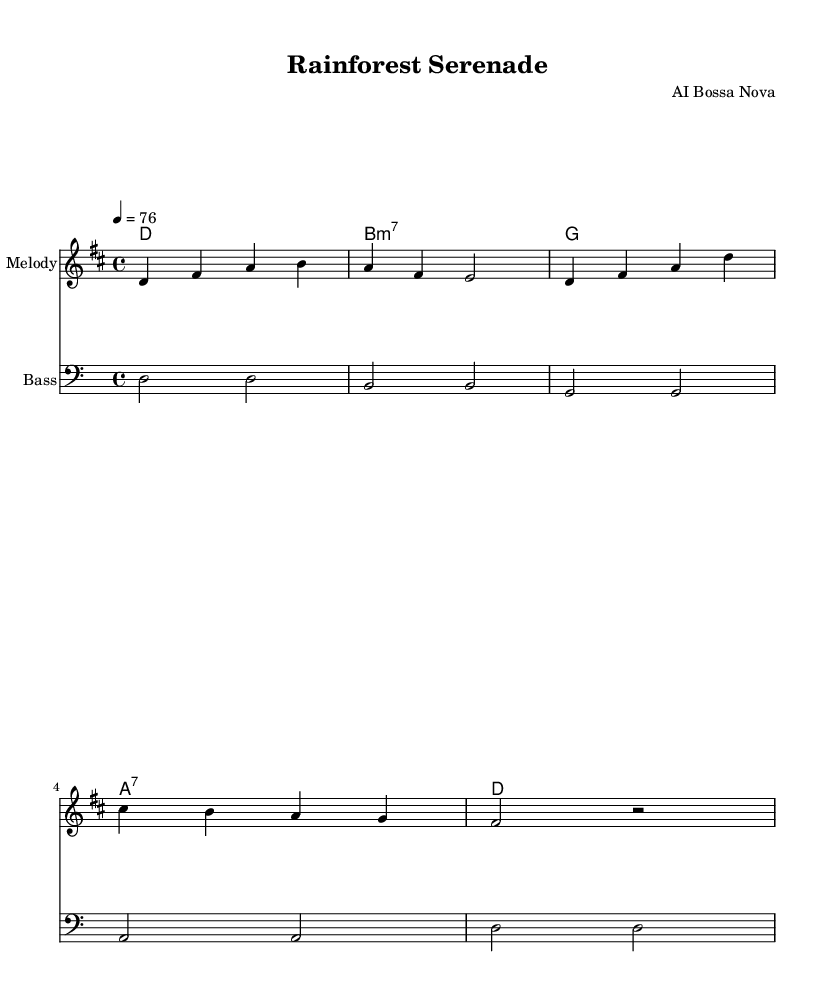What is the key signature of this music? The key signature is D major, which has two sharps (F# and C#). This can be identified at the beginning of the staff where the key signature is indicated.
Answer: D major What is the time signature of this music? The time signature is 4/4, which is depicted at the beginning of the sheet music. This indicates that there are four beats in each measure and that the quarter note gets one beat.
Answer: 4/4 What is the tempo marking for the piece? The tempo marking is "4 = 76", which means that the quarter note should be played at a speed of 76 beats per minute. This is commonly found at the start, indicating the intended performance speed.
Answer: 76 How many measures are there in the melody section? The melody section contains four measures, which can be counted by observing the bar lines separating each measure in the written music.
Answer: 4 What type of seventh chord is used in the harmonies? The seventh chord used is B minor 7 (b7). This can be determined by inspecting the chord notations written in the harmonies line, where the b indicates it is a minor chord with a seventh included.
Answer: B7:m7 What instrument is designated for the melody? The instrument designated for the melody is "Melody." This is indicated in the score next to the staff labeled with the instrument name.
Answer: Melody What musical style does this piece represent? This piece represents the Bossa Nova style, which is a fusion of samba and jazz. The rhythm and harmony are characteristic of this genre, often promoting relaxation and a laid-back feel.
Answer: Bossa Nova 